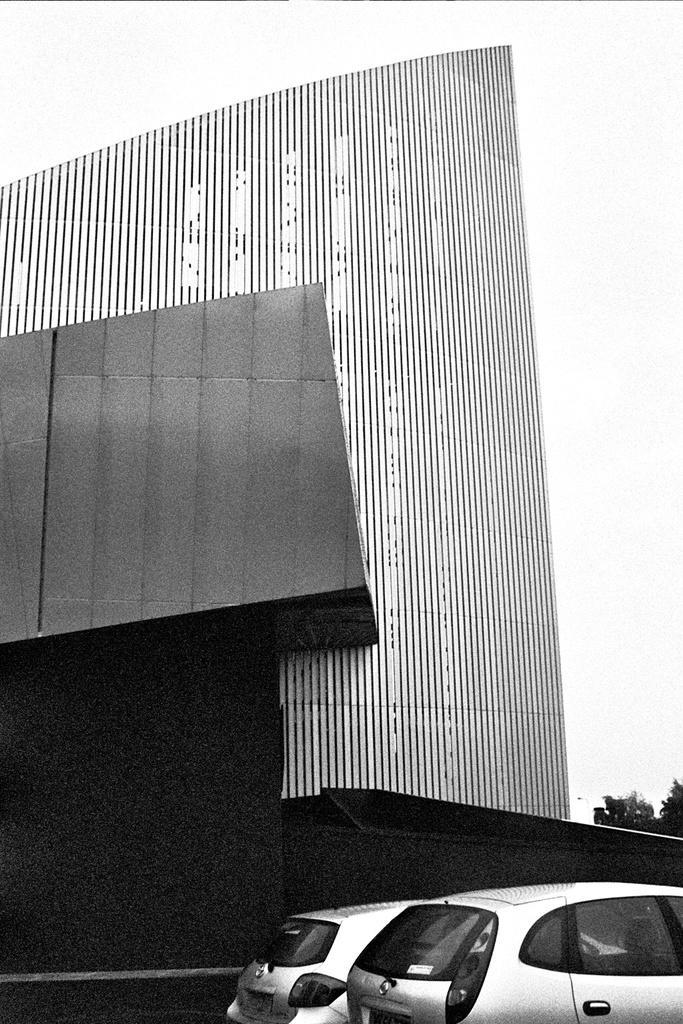In one or two sentences, can you explain what this image depicts? In front of the image there are cars. Behind the cars there is a building. There are trees. 